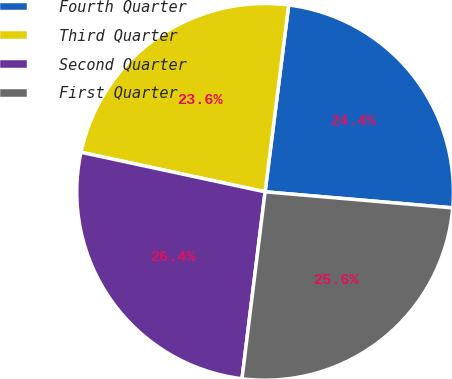Convert chart. <chart><loc_0><loc_0><loc_500><loc_500><pie_chart><fcel>Fourth Quarter<fcel>Third Quarter<fcel>Second Quarter<fcel>First Quarter<nl><fcel>24.36%<fcel>23.63%<fcel>26.41%<fcel>25.6%<nl></chart> 